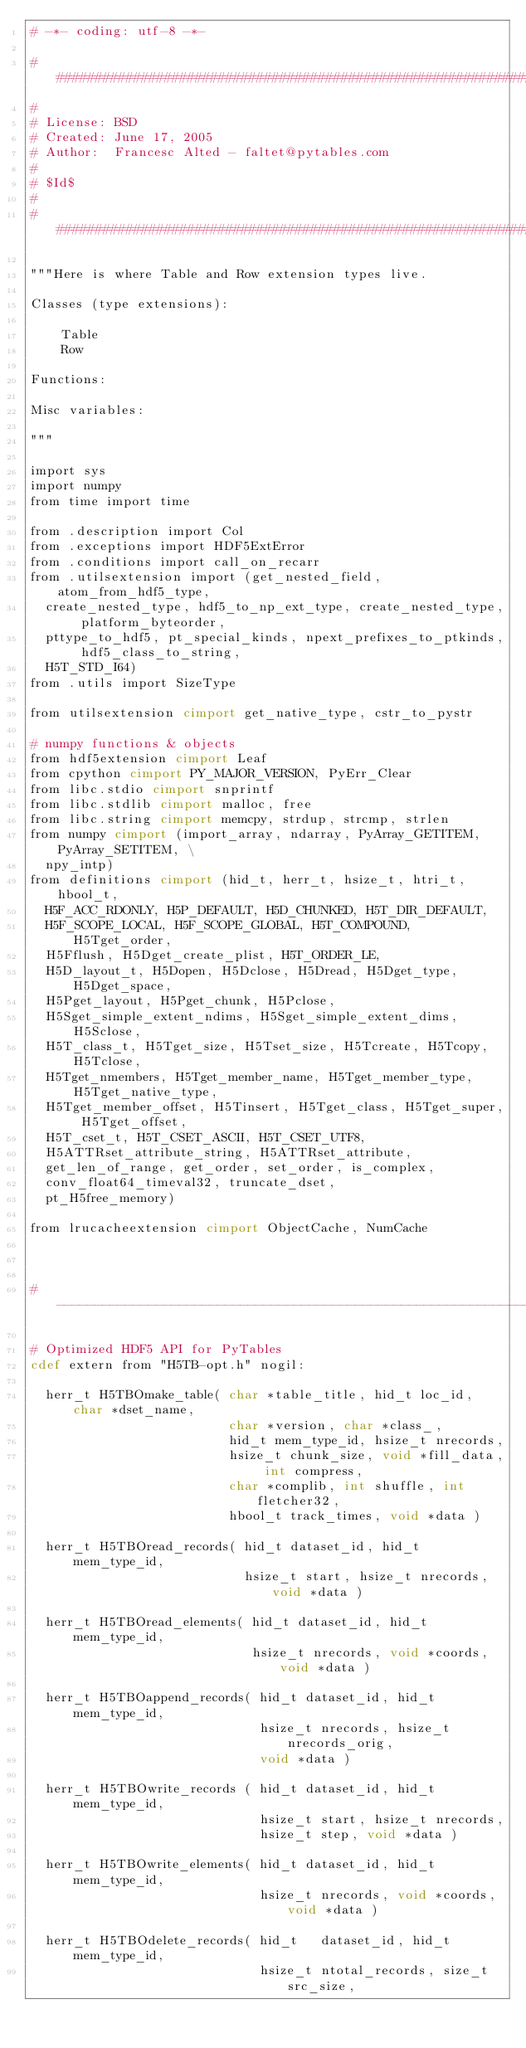Convert code to text. <code><loc_0><loc_0><loc_500><loc_500><_Cython_># -*- coding: utf-8 -*-

########################################################################
#
# License: BSD
# Created: June 17, 2005
# Author:  Francesc Alted - faltet@pytables.com
#
# $Id$
#
########################################################################

"""Here is where Table and Row extension types live.

Classes (type extensions):

    Table
    Row

Functions:

Misc variables:

"""

import sys
import numpy
from time import time

from .description import Col
from .exceptions import HDF5ExtError
from .conditions import call_on_recarr
from .utilsextension import (get_nested_field, atom_from_hdf5_type,
  create_nested_type, hdf5_to_np_ext_type, create_nested_type, platform_byteorder,
  pttype_to_hdf5, pt_special_kinds, npext_prefixes_to_ptkinds, hdf5_class_to_string,
  H5T_STD_I64)
from .utils import SizeType

from utilsextension cimport get_native_type, cstr_to_pystr

# numpy functions & objects
from hdf5extension cimport Leaf
from cpython cimport PY_MAJOR_VERSION, PyErr_Clear
from libc.stdio cimport snprintf
from libc.stdlib cimport malloc, free
from libc.string cimport memcpy, strdup, strcmp, strlen
from numpy cimport (import_array, ndarray, PyArray_GETITEM, PyArray_SETITEM, \
  npy_intp)
from definitions cimport (hid_t, herr_t, hsize_t, htri_t, hbool_t,
  H5F_ACC_RDONLY, H5P_DEFAULT, H5D_CHUNKED, H5T_DIR_DEFAULT,
  H5F_SCOPE_LOCAL, H5F_SCOPE_GLOBAL, H5T_COMPOUND, H5Tget_order,
  H5Fflush, H5Dget_create_plist, H5T_ORDER_LE,
  H5D_layout_t, H5Dopen, H5Dclose, H5Dread, H5Dget_type, H5Dget_space,
  H5Pget_layout, H5Pget_chunk, H5Pclose,
  H5Sget_simple_extent_ndims, H5Sget_simple_extent_dims, H5Sclose,
  H5T_class_t, H5Tget_size, H5Tset_size, H5Tcreate, H5Tcopy, H5Tclose,
  H5Tget_nmembers, H5Tget_member_name, H5Tget_member_type, H5Tget_native_type,
  H5Tget_member_offset, H5Tinsert, H5Tget_class, H5Tget_super, H5Tget_offset,
  H5T_cset_t, H5T_CSET_ASCII, H5T_CSET_UTF8,
  H5ATTRset_attribute_string, H5ATTRset_attribute,
  get_len_of_range, get_order, set_order, is_complex,
  conv_float64_timeval32, truncate_dset,
  pt_H5free_memory)

from lrucacheextension cimport ObjectCache, NumCache



#-----------------------------------------------------------------

# Optimized HDF5 API for PyTables
cdef extern from "H5TB-opt.h" nogil:

  herr_t H5TBOmake_table( char *table_title, hid_t loc_id, char *dset_name,
                          char *version, char *class_,
                          hid_t mem_type_id, hsize_t nrecords,
                          hsize_t chunk_size, void *fill_data, int compress,
                          char *complib, int shuffle, int fletcher32,
                          hbool_t track_times, void *data )

  herr_t H5TBOread_records( hid_t dataset_id, hid_t mem_type_id,
                            hsize_t start, hsize_t nrecords, void *data )

  herr_t H5TBOread_elements( hid_t dataset_id, hid_t mem_type_id,
                             hsize_t nrecords, void *coords, void *data )

  herr_t H5TBOappend_records( hid_t dataset_id, hid_t mem_type_id,
                              hsize_t nrecords, hsize_t nrecords_orig,
                              void *data )

  herr_t H5TBOwrite_records ( hid_t dataset_id, hid_t mem_type_id,
                              hsize_t start, hsize_t nrecords,
                              hsize_t step, void *data )

  herr_t H5TBOwrite_elements( hid_t dataset_id, hid_t mem_type_id,
                              hsize_t nrecords, void *coords, void *data )

  herr_t H5TBOdelete_records( hid_t   dataset_id, hid_t   mem_type_id,
                              hsize_t ntotal_records, size_t  src_size,</code> 